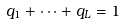<formula> <loc_0><loc_0><loc_500><loc_500>q _ { 1 } + \dots + q _ { L } = 1</formula> 